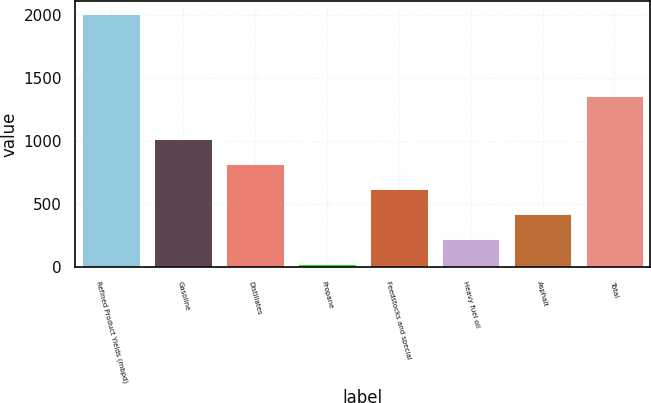<chart> <loc_0><loc_0><loc_500><loc_500><bar_chart><fcel>Refined Product Yields (mbpd)<fcel>Gasoline<fcel>Distillates<fcel>Propane<fcel>Feedstocks and special<fcel>Heavy fuel oil<fcel>Asphalt<fcel>Total<nl><fcel>2010<fcel>1017<fcel>818.4<fcel>24<fcel>619.8<fcel>222.6<fcel>421.2<fcel>1356<nl></chart> 